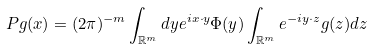Convert formula to latex. <formula><loc_0><loc_0><loc_500><loc_500>P g ( x ) = ( 2 \pi ) ^ { - m } \int _ { \mathbb { R } ^ { m } } d y e ^ { i x \cdot y } \Phi ( y ) \int _ { \mathbb { R } ^ { m } } e ^ { - i y \cdot z } g ( z ) d z</formula> 